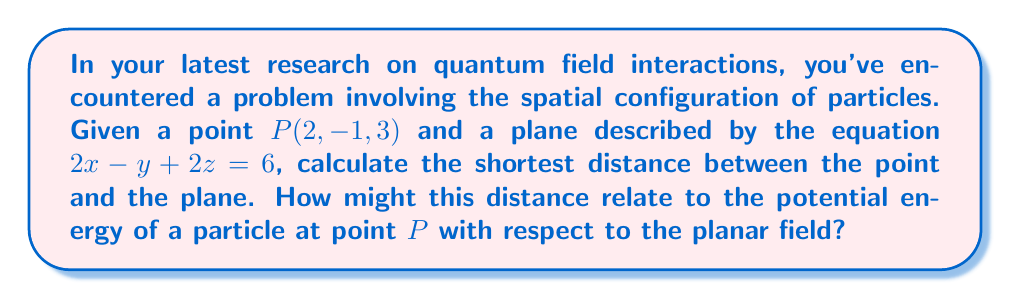Could you help me with this problem? To find the shortest distance between a point and a plane in 3D space, we can use the formula:

$$ d = \frac{|Ax_0 + By_0 + Cz_0 + D|}{\sqrt{A^2 + B^2 + C^2}} $$

where $(x_0, y_0, z_0)$ are the coordinates of the point, and $Ax + By + Cz + D = 0$ is the general equation of the plane.

Given:
- Point $P(2, -1, 3)$
- Plane equation: $2x - y + 2z = 6$

Step 1: Identify the coefficients in the plane equation.
$A = 2$, $B = -1$, $C = 2$, $D = -6$ (after moving 6 to the left side)

Step 2: Substitute the values into the distance formula.
$$ d = \frac{|2(2) + (-1)(-1) + 2(3) + (-6)|}{\sqrt{2^2 + (-1)^2 + 2^2}} $$

Step 3: Simplify the numerator.
$$ d = \frac{|4 + 1 + 6 - 6|}{\sqrt{4 + 1 + 4}} = \frac{|5|}{\sqrt{9}} $$

Step 4: Calculate the final result.
$$ d = \frac{5}{3} \approx 1.67 $$

The shortest distance between the point $P(2, -1, 3)$ and the plane $2x - y + 2z = 6$ is $\frac{5}{3}$ units.

In the context of quantum field interactions, this distance could be proportional to the potential energy of a particle at point $P$ with respect to the planar field. The closer the particle is to the plane, the stronger the interaction might be, potentially following an inverse relationship.
Answer: The shortest distance between the point $P(2, -1, 3)$ and the plane $2x - y + 2z = 6$ is $\frac{5}{3}$ units (approximately 1.67 units). 